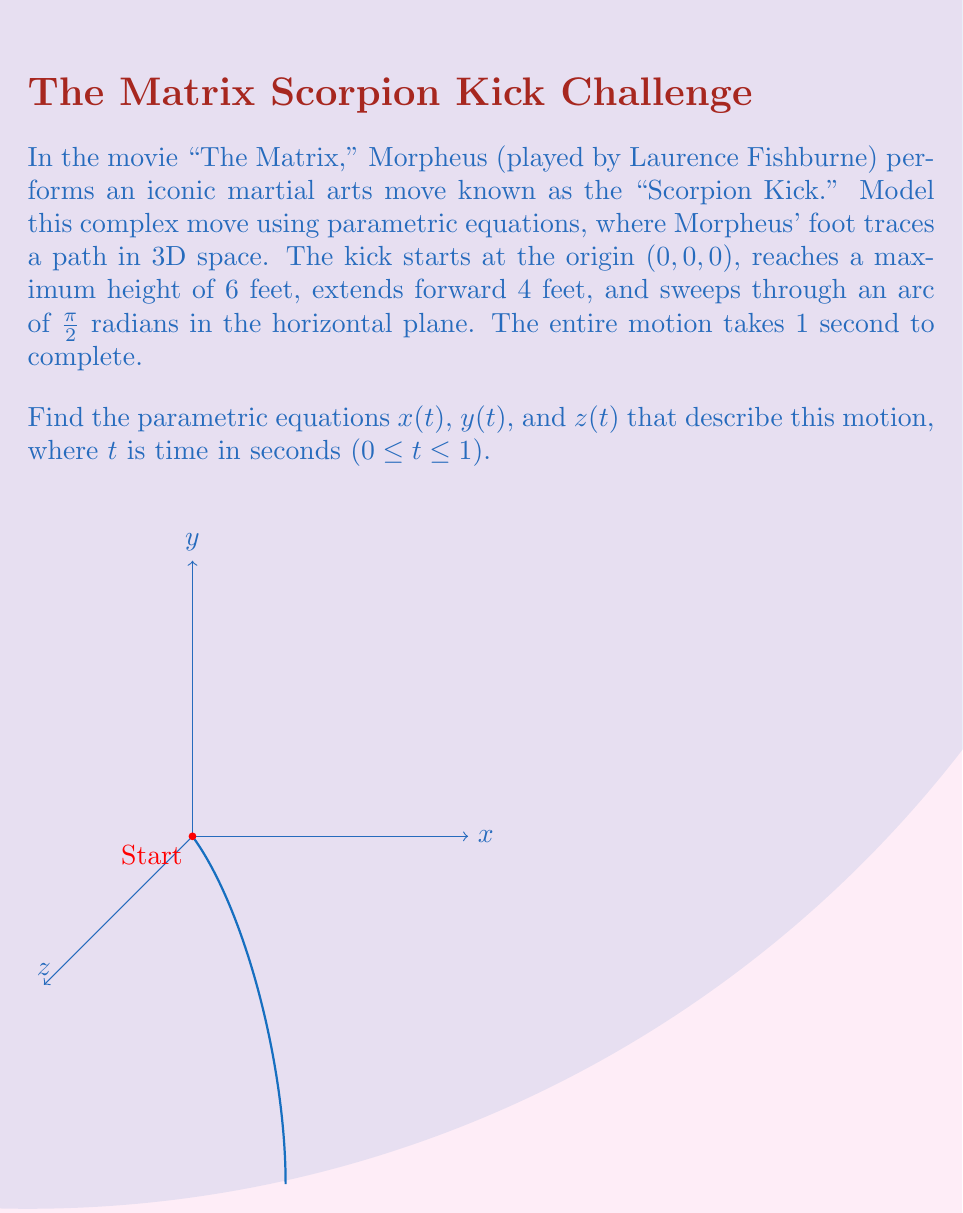Teach me how to tackle this problem. Let's break down the motion into its components and develop the parametric equations step by step:

1. x-component (forward motion):
   The kick extends 4 feet forward, following a sinusoidal path to create a smooth motion.
   $$x(t) = 4 \sin(\frac{\pi t}{2})$$

2. y-component (sideways arc):
   The kick sweeps through an arc of π/2 radians in the horizontal plane, starting at y = -4 and ending at y = 0.
   $$y(t) = 4 \cos(\frac{\pi t}{2}) - 4$$

3. z-component (vertical motion):
   The kick reaches a maximum height of 6 feet, following a sinusoidal path for smooth up and down motion.
   $$z(t) = 6 \sin(\pi t)$$

4. Time parameter:
   The entire motion takes 1 second, so t ranges from 0 to 1.
   $$0 \leq t \leq 1$$

These equations ensure that:
- At t = 0: (x, y, z) = (0, -4, 0), the starting position
- At t = 0.5: (x, y, z) ≈ (4, -2, 6), the highest point of the kick
- At t = 1: (x, y, z) = (4, 0, 0), the end position

The resulting parametric equations model Morpheus' "Scorpion Kick" as a smooth, continuous motion in 3D space, capturing the forward extension, sideways arc, and vertical component of the complex martial arts move.
Answer: $$x(t) = 4 \sin(\frac{\pi t}{2}), y(t) = 4 \cos(\frac{\pi t}{2}) - 4, z(t) = 6 \sin(\pi t), 0 \leq t \leq 1$$ 